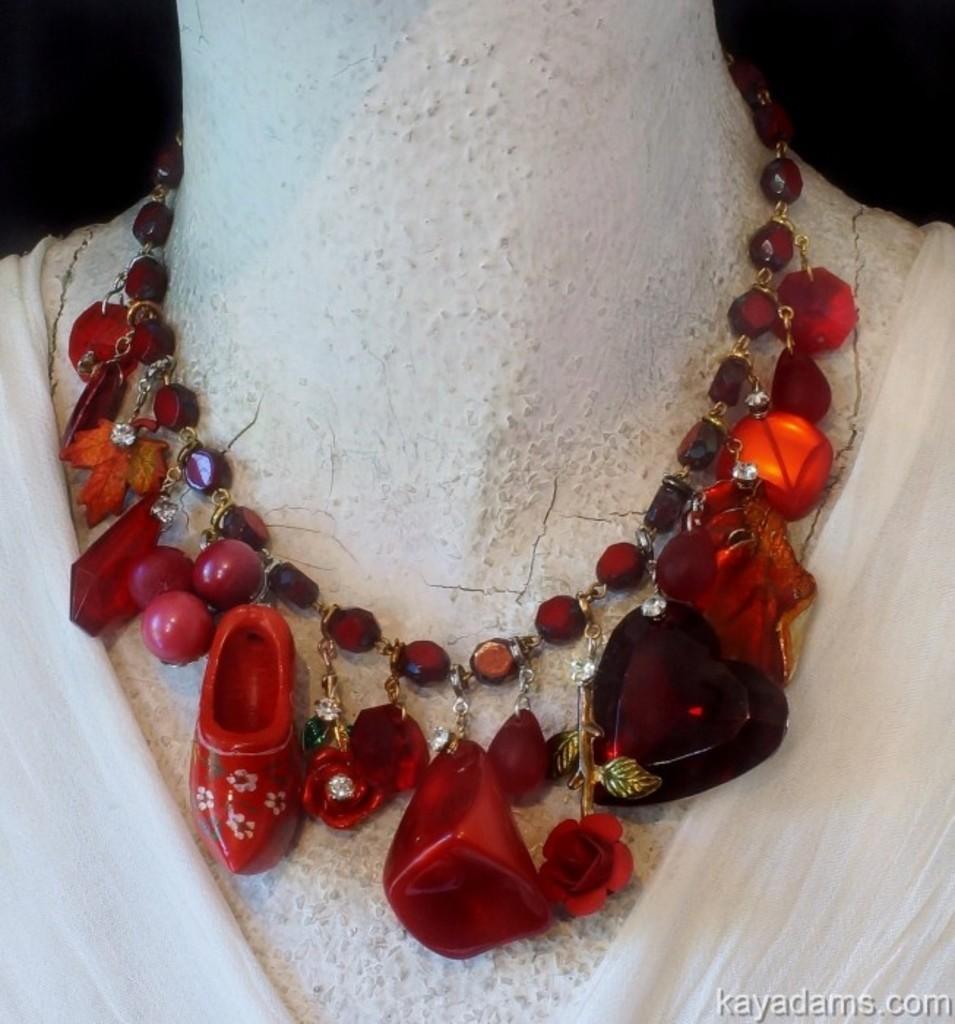How would you summarize this image in a sentence or two? In this picture there is a red color necklace to a mannequin and there is white color cloth in the bottom right and left side of the image. 